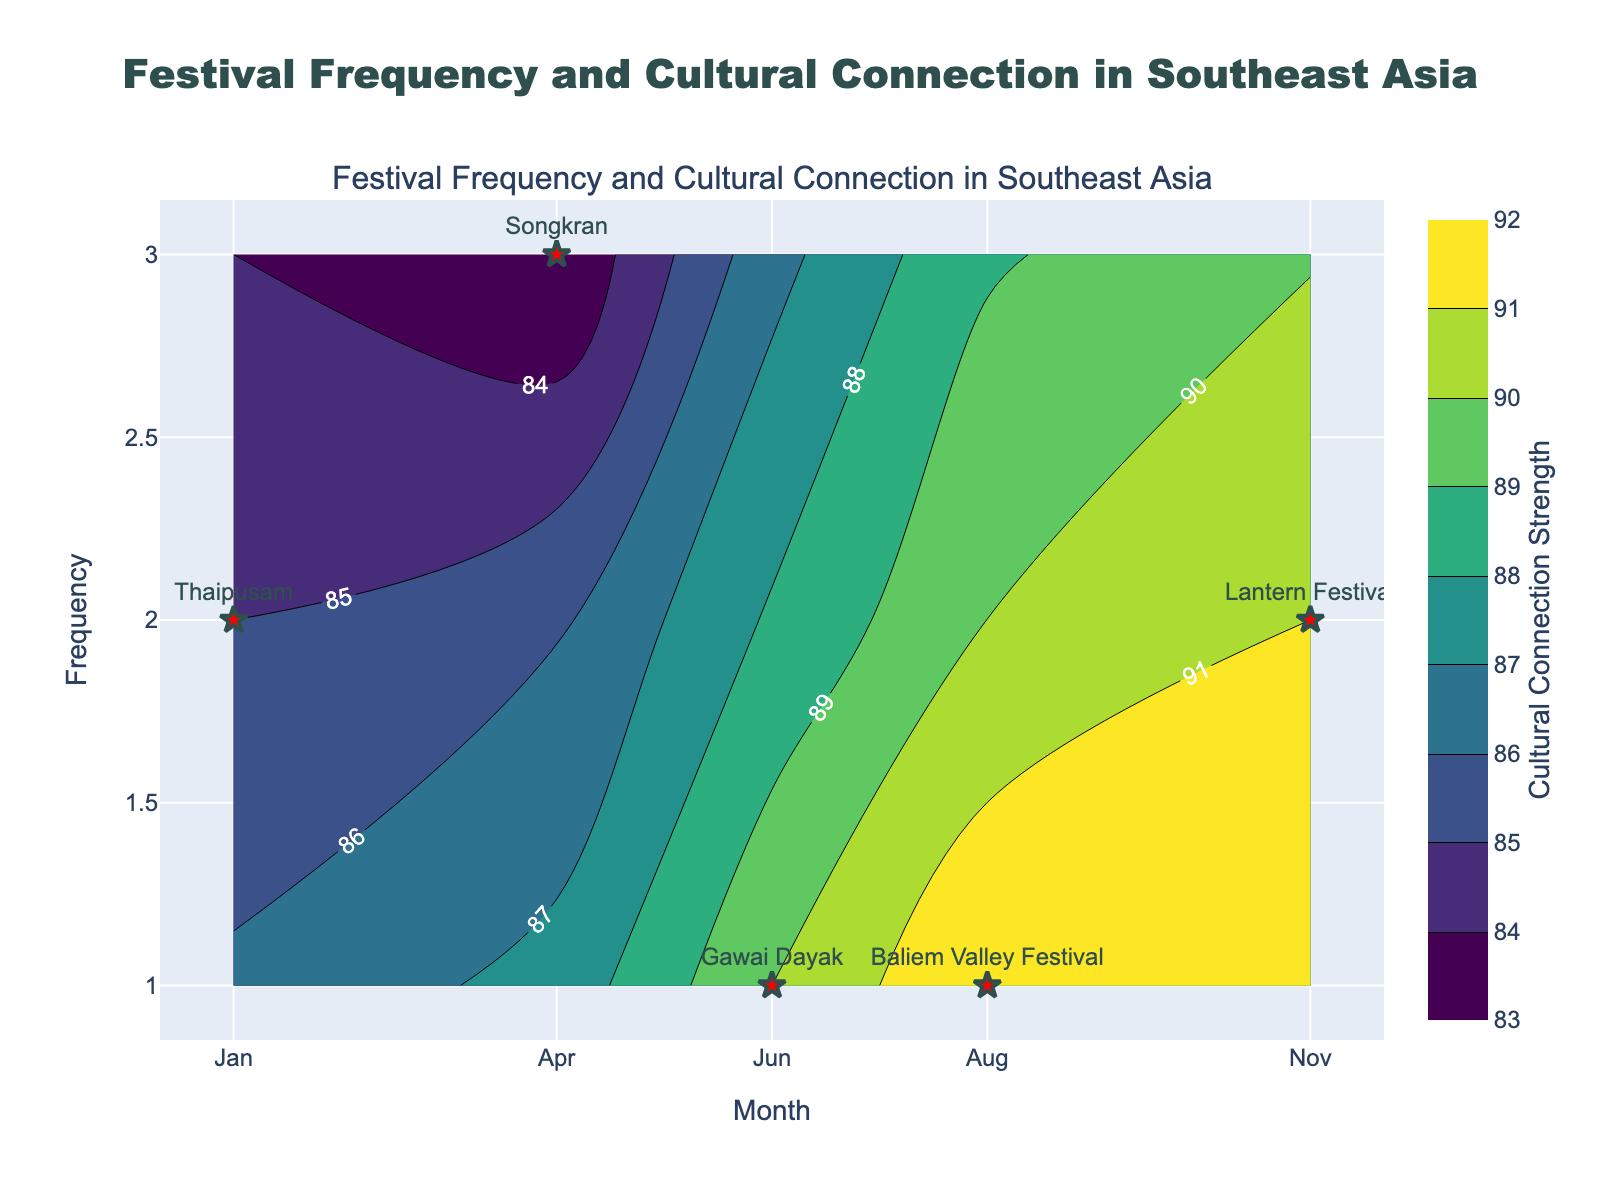What is the title of the figure? The title is given at the top center of the figure and reads "Festival Frequency and Cultural Connection in Southeast Asia".
Answer: Festival Frequency and Cultural Connection in Southeast Asia What does the color scale represent? The color scale on the right side of the figure, labeled "Cultural Connection Strength", indicates the strength of the connection to local customs based on the length of the description.
Answer: Cultural Connection Strength During which month does the festival with the highest frequency occur? Looking at the scatter points, the highest frequency value of 3 (corresponding to Songkran) appears in April.
Answer: April Which festival has the strongest connection to local customs? The contour plot shows the highest connection strength at a specific (x, y) coordinate; Songkran in April shows the highest connection.
Answer: Songkran How many festivals occur in June, and what are their connection strengths? By locating the June coordinate on the x-axis and identifying the scatter points, you see there's one festival in June (Gawai Dayak) with a connection strength determined by the contour color at that point. Using the color scale, we approximate this strength.
Answer: 1, medium Compare the connection strengths between Songkran and Thaipusam. Which is higher? Songkran has a higher connection strength than Thaipusam; this can be seen from the contour levels and colors for April and January, respectively, where April's (Songkran's) contour color is darker.
Answer: Songkran Which country has festivals in both January and November, and what are those festivals' frequencies? Thailand is the country with festivals in both January (Thaipusam) and November (Lantern Festival). Their frequencies can be determined from scatter points.
Answer: Thailand, 2 Based on the plot, which festival happens in Indonesia during August, and what can be inferred about its connection strength? There is one festival in August in Indonesia, Baliem Valley Festival. The contour color at this point reveals its connection strength using the color bar.
Answer: Baliem Valley Festival, strong 